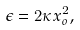<formula> <loc_0><loc_0><loc_500><loc_500>\epsilon = 2 \kappa x _ { o } ^ { 2 } ,</formula> 